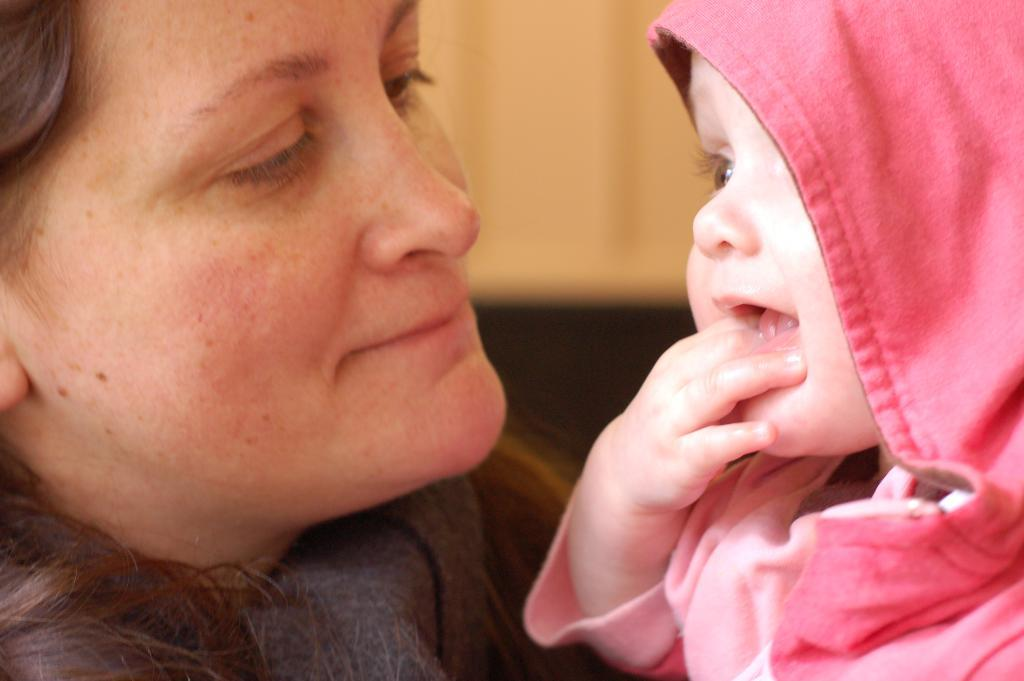What is the gender of the person on the left side of the image? There is a woman on the left side of the image. What is the gender of the person on the right side of the image? There is a kid on the right side of the image. What is the emotional state of the kid in the image? The kid is smiling. What type of grain is being harvested by the doctor in the image? There is no doctor or grain present in the image. What part of the kid's body is being examined by the doctor in the image? There is no doctor or examination of the kid's body in the image. 